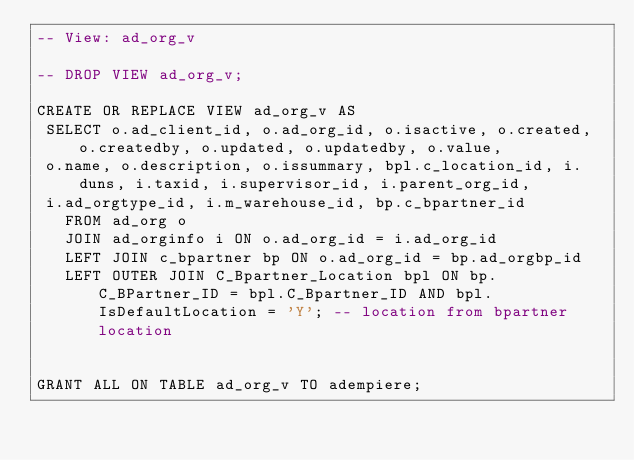<code> <loc_0><loc_0><loc_500><loc_500><_SQL_>-- View: ad_org_v

-- DROP VIEW ad_org_v;

CREATE OR REPLACE VIEW ad_org_v AS 
 SELECT o.ad_client_id, o.ad_org_id, o.isactive, o.created, o.createdby, o.updated, o.updatedby, o.value, 
 o.name, o.description, o.issummary, bpl.c_location_id, i.duns, i.taxid, i.supervisor_id, i.parent_org_id, 
 i.ad_orgtype_id, i.m_warehouse_id, bp.c_bpartner_id
   FROM ad_org o
   JOIN ad_orginfo i ON o.ad_org_id = i.ad_org_id
   LEFT JOIN c_bpartner bp ON o.ad_org_id = bp.ad_orgbp_id
   LEFT OUTER JOIN C_Bpartner_Location bpl ON bp.C_BPartner_ID = bpl.C_Bpartner_ID AND bpl.IsDefaultLocation = 'Y'; -- location from bpartner location


GRANT ALL ON TABLE ad_org_v TO adempiere;


</code> 